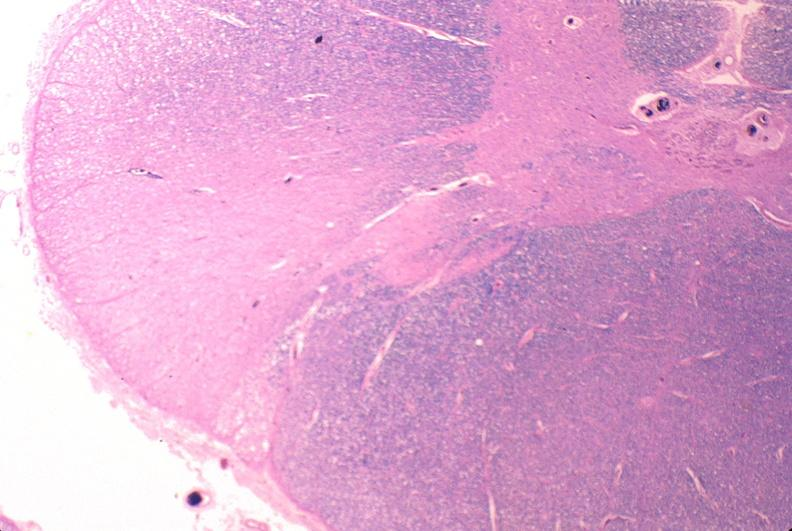does small intestine show spinal cord injury due to vertebral column trauma, demyelination?
Answer the question using a single word or phrase. No 